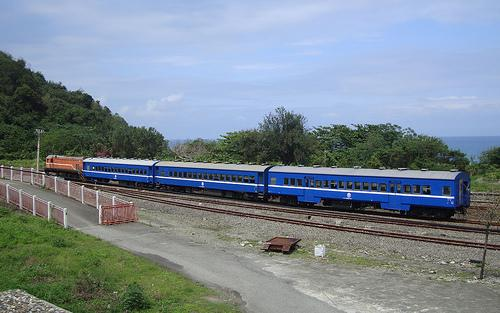Is there any presence of an electrical or lighting infrastructure near the train tracks? Yes, there is an electrical pole and a train light pole beside the train tracks. Identify the natural elements present in the scene, such as vegetation and weather formations. The scene features green trees, bushes, grass, a dead brown bush, a small bare tree, and white clouds in the blue sky. Describe the overall environment where the train and the train tracks are running in the image. The train is running on the tracks amidst an outdoor scene that features green vegetation, a grey concrete pathway, and a fence. The sky is blue with wispy white clouds. Provide a description of the state of the surrounding landscape, including details on natural and man-made objects. The landscape hosts tall green bushes on a hill, trees lining the railroad tracks, a patch of rocky grey gravel, and a red and white fence with white posts. How many blue train carts can be seen and how would you describe their length? There are three long blue train carts in the image. Comment on the amount of wear or rust on the objects in the image, if any. There is a piece of brown rusted metal and a rusted flat truck bed in the image, indicating some wear. Does the image depict any specific location or landmark? The image does not reveal a specific location or landmark, it just shows an outdoor scene near some railroad tracks. Describe the general sentiment or emotion this image evokes. The image gives off a peaceful and serene sentiment, with the train passing through a natural, outdoor area. What type of train does this image depict, including its color? Mention any additional cars attached to it. The image shows a blue and orange passenger train with many windows, and a red train engine attached. What type of collision structure is placed adjacent to the train tracks in the image? There is a red and white fence placed adjacent to the train tracks to serve as a collision barrier. 